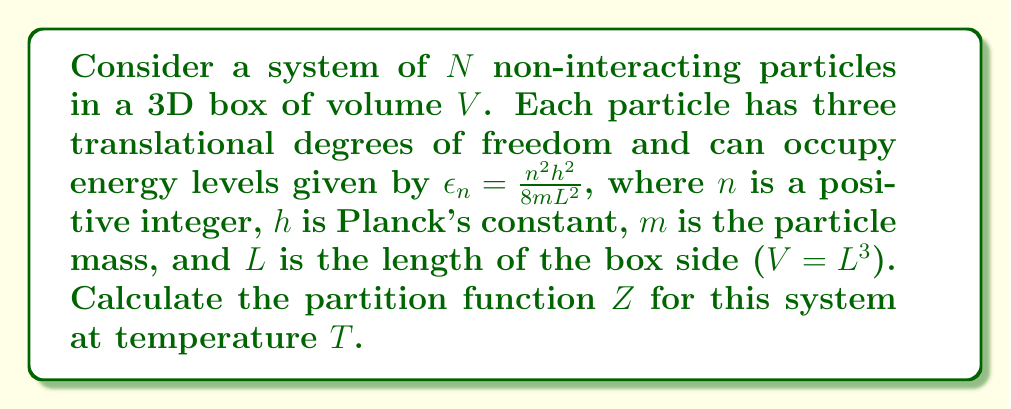Can you solve this math problem? 1) For a system of non-interacting particles, the total partition function is the product of individual particle partition functions:

   $$Z = (z)^N$$

   where $z$ is the single-particle partition function.

2) The single-particle partition function is the sum over all possible energy states:

   $$z = \sum_{n_x=1}^{\infty} \sum_{n_y=1}^{\infty} \sum_{n_z=1}^{\infty} e^{-\beta\epsilon_{n_x,n_y,n_z}}$$

   where $\beta = \frac{1}{k_BT}$, $k_B$ is Boltzmann's constant, and $\epsilon_{n_x,n_y,n_z} = \frac{h^2}{8mL^2}(n_x^2 + n_y^2 + n_z^2)$.

3) In the classical limit (high temperature or large volume), we can approximate the sum by an integral:

   $$z \approx \frac{V}{h^3} \int_0^{\infty} \int_0^{\infty} \int_0^{\infty} e^{-\beta\epsilon_{p_x,p_y,p_z}} dp_x dp_y dp_z$$

   where $\epsilon_{p_x,p_y,p_z} = \frac{p_x^2 + p_y^2 + p_z^2}{2m}$.

4) This integral can be evaluated to give:

   $$z = V \left(\frac{2\pi m k_B T}{h^2}\right)^{3/2}$$

5) Therefore, the total partition function is:

   $$Z = \left[V \left(\frac{2\pi m k_B T}{h^2}\right)^{3/2}\right]^N$$
Answer: $$Z = \left[V \left(\frac{2\pi m k_B T}{h^2}\right)^{3/2}\right]^N$$ 